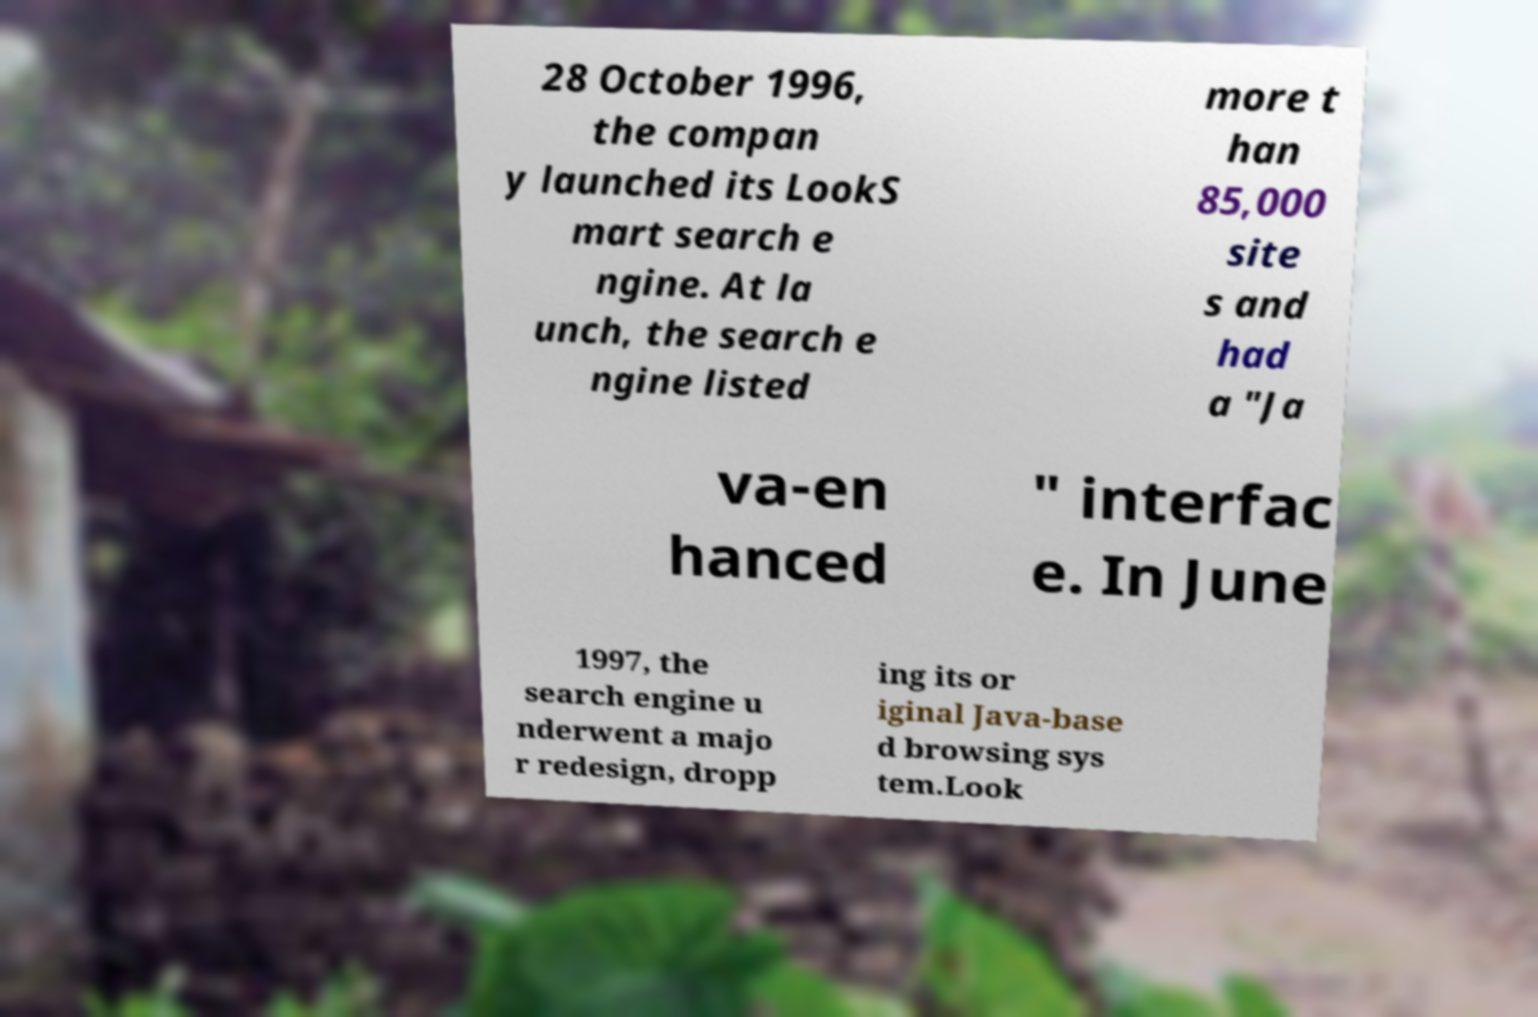I need the written content from this picture converted into text. Can you do that? 28 October 1996, the compan y launched its LookS mart search e ngine. At la unch, the search e ngine listed more t han 85,000 site s and had a "Ja va-en hanced " interfac e. In June 1997, the search engine u nderwent a majo r redesign, dropp ing its or iginal Java-base d browsing sys tem.Look 